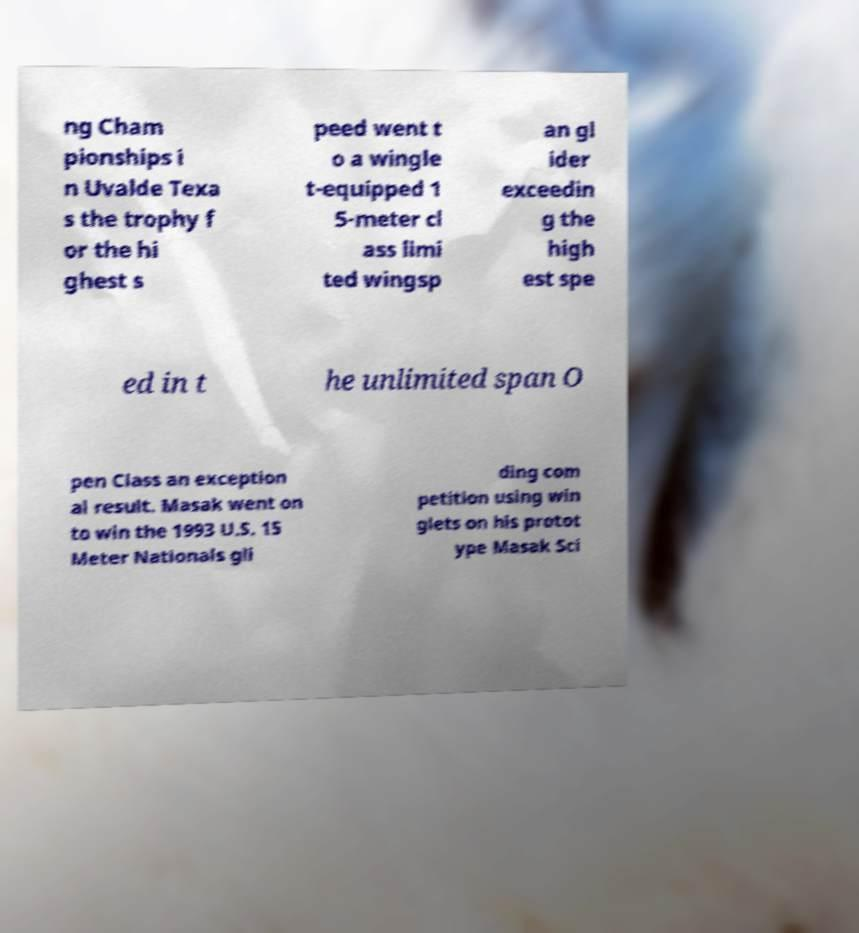Could you assist in decoding the text presented in this image and type it out clearly? ng Cham pionships i n Uvalde Texa s the trophy f or the hi ghest s peed went t o a wingle t-equipped 1 5-meter cl ass limi ted wingsp an gl ider exceedin g the high est spe ed in t he unlimited span O pen Class an exception al result. Masak went on to win the 1993 U.S. 15 Meter Nationals gli ding com petition using win glets on his protot ype Masak Sci 